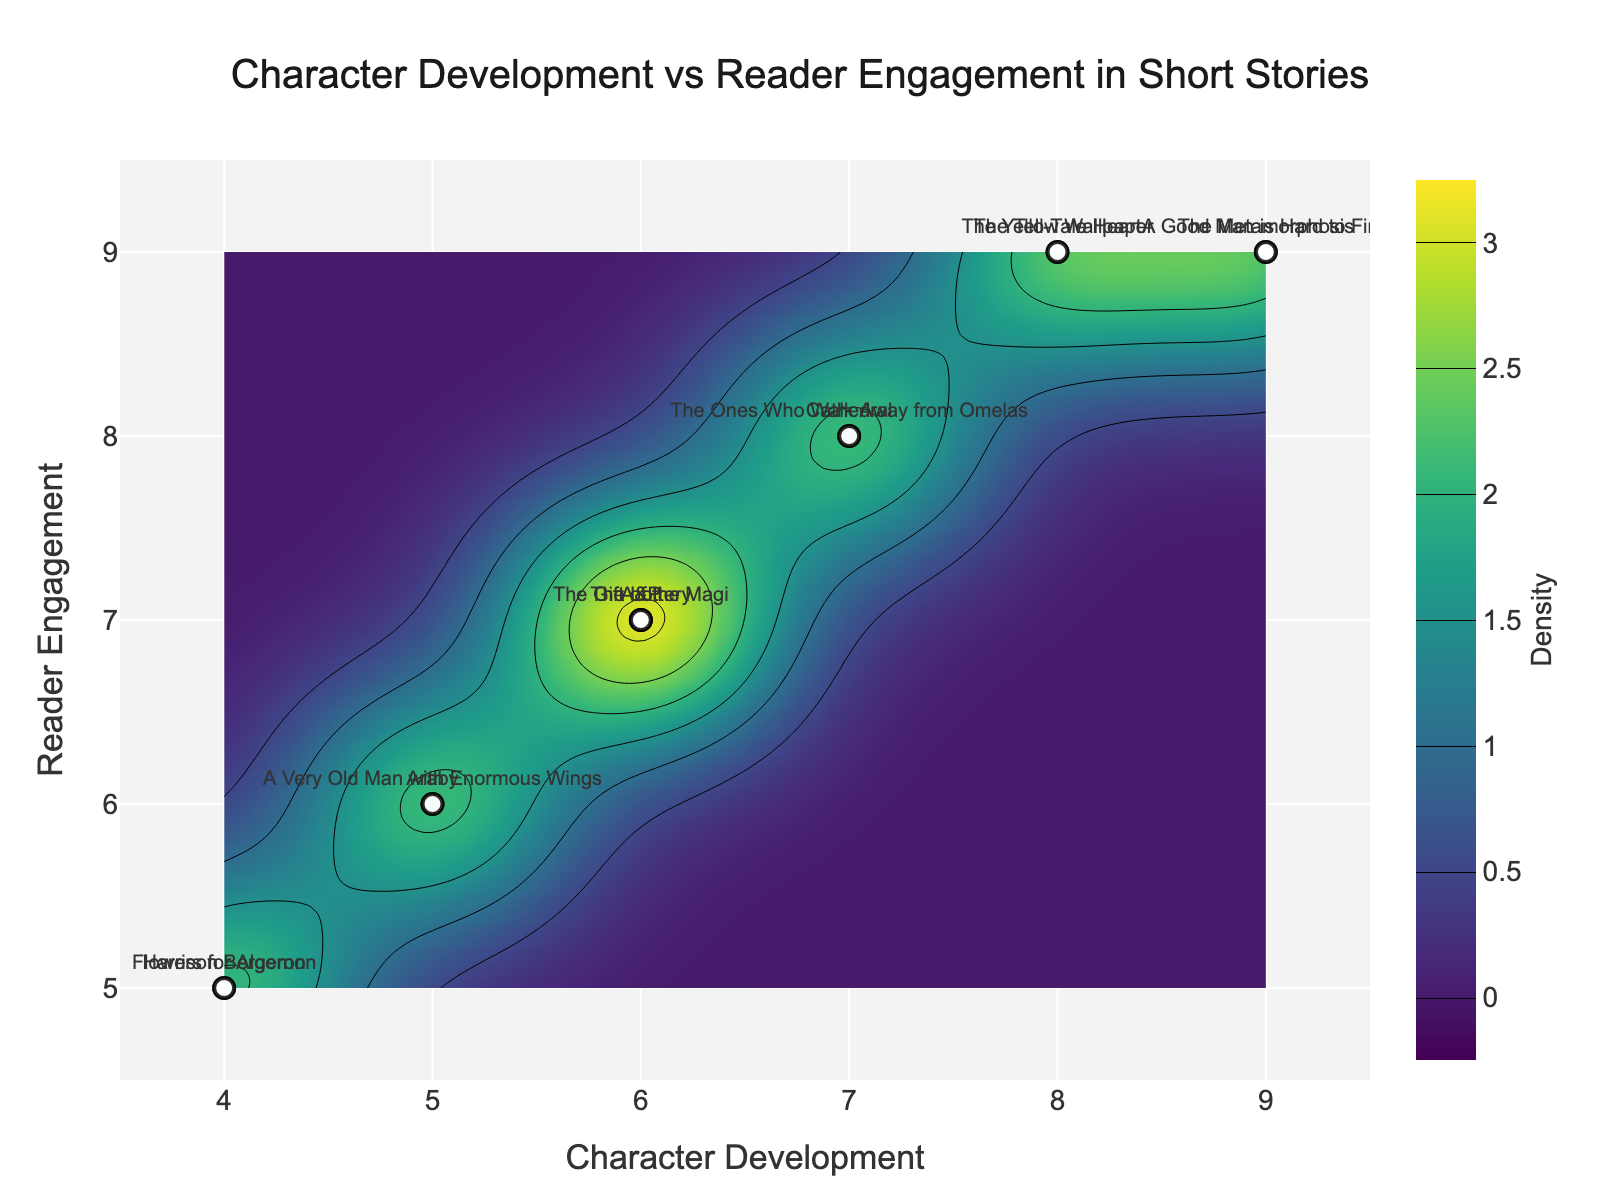What is the title of the plot? The title is located at the very top of the figure, in larger font size and centered.
Answer: Character Development vs Reader Engagement in Short Stories How many data points are plotted on the scatter plot? You can count the number of markers on the scatter plot to determine the number of data points. There are 13 different story titles listed, hence 13 data points.
Answer: 13 What are the axes labels for this contour plot? The labels for axes can be found along the x-axis and y-axis of the plot respectively.
Answer: Character Development (x-axis), Reader Engagement (y-axis) Which story has the highest character development and reader engagement? Look for the data point that is located at the upper right corner of the plot. The story title should be annotated next to it.
Answer: The Metamorphosis Between "A&P" and "The Lottery," which story has higher character development? Compare the positions of these two specific data points on the x-axis. "A&P" is at 6, while "The Lottery" is also at 6; they are equal.
Answer: Equal Is there a trend between character development and reader engagement? By observing the overall pattern of the scatter plot and the contour lines, one can infer that higher character development tends to correlate with higher reader engagement.
Answer: Yes What's the general range of density values in the contour plot? The density values are represented by the color intensity in the contour plot, the color bar on the right side of the plot indicates the range from start to end.
Answer: 0 to maximum density Do most stories have a character development score above 6? By looking at the scatter plot points just above the x-axis ticks, we can see the majority of points are at or above 6.
Answer: Yes Which story lies closest to the value (5,6) in Character Development and Reader Engagement? Identify the data point that is closest to coordinate (5, 6) on the plot and check the title annotated next to it.
Answer: Araby How does "Harrison Bergeron" compare to "A Good Man is Hard to Find" in terms of reader engagement? Compare their positions on the y-axis. "Harrison Bergeron" is at 5, while "A Good Man is Hard to Find" is at 9.
Answer: A Good Man is Hard to Find has higher reader engagement 